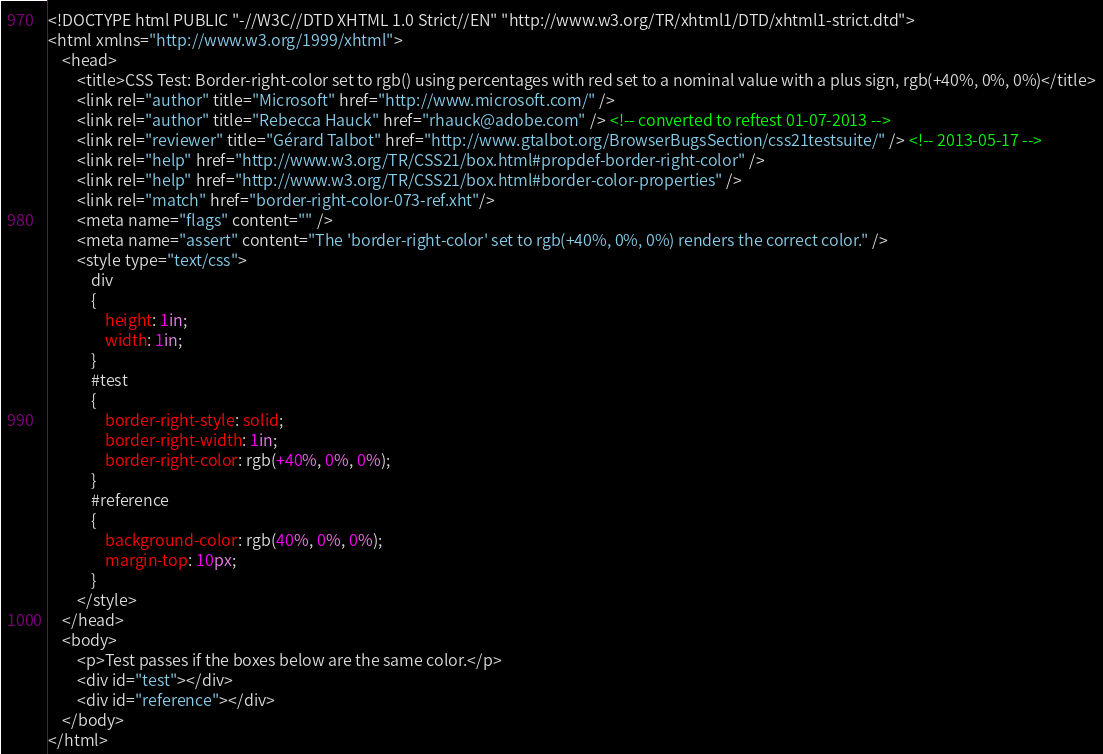Convert code to text. <code><loc_0><loc_0><loc_500><loc_500><_HTML_><!DOCTYPE html PUBLIC "-//W3C//DTD XHTML 1.0 Strict//EN" "http://www.w3.org/TR/xhtml1/DTD/xhtml1-strict.dtd">
<html xmlns="http://www.w3.org/1999/xhtml">
    <head>
        <title>CSS Test: Border-right-color set to rgb() using percentages with red set to a nominal value with a plus sign, rgb(+40%, 0%, 0%)</title>
        <link rel="author" title="Microsoft" href="http://www.microsoft.com/" />
        <link rel="author" title="Rebecca Hauck" href="rhauck@adobe.com" /> <!-- converted to reftest 01-07-2013 -->
        <link rel="reviewer" title="Gérard Talbot" href="http://www.gtalbot.org/BrowserBugsSection/css21testsuite/" /> <!-- 2013-05-17 -->
        <link rel="help" href="http://www.w3.org/TR/CSS21/box.html#propdef-border-right-color" />
        <link rel="help" href="http://www.w3.org/TR/CSS21/box.html#border-color-properties" />
        <link rel="match" href="border-right-color-073-ref.xht"/>
        <meta name="flags" content="" />
        <meta name="assert" content="The 'border-right-color' set to rgb(+40%, 0%, 0%) renders the correct color." />
        <style type="text/css">
            div
            {
                height: 1in;
                width: 1in;
            }
            #test
            {
                border-right-style: solid;
                border-right-width: 1in;
                border-right-color: rgb(+40%, 0%, 0%);
            }
            #reference
            {
                background-color: rgb(40%, 0%, 0%);
                margin-top: 10px;
            }
        </style>
    </head>
    <body>
        <p>Test passes if the boxes below are the same color.</p>
        <div id="test"></div>
        <div id="reference"></div>
    </body>
</html></code> 